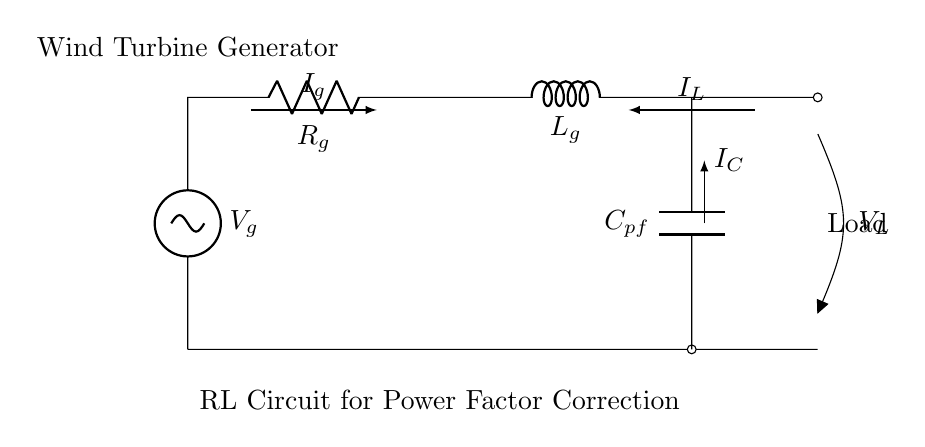What is the voltage source in this circuit? The voltage source is labeled Vg at the top left of the circuit diagram, indicating it provides the input voltage for the RL circuit.
Answer: Vg What component is placed after the resistor? The component that follows the resistor in the circuit layout is an inductor, indicated by the label Lg positioned directly after the resistor Rg.
Answer: Lg What is the purpose of the capacitor in this circuit? The capacitor, labeled Cpf, serves the purpose of power factor correction, helping to improve the circuit's efficiency by compensating for the inductive load created by the inductor Lg.
Answer: Power factor correction What are the current directions in this circuit? The diagram shows that there are three currents: Ig flowing through the generator to the resistor, Il flowing to the load, and Ic flowing through the capacitor. The arrows indicate the direction of current flow in each section.
Answer: Ig, Il, Ic How does the presence of the inductor affect the circuit? The inductor creates a phase difference between the voltage and current, introducing inductive reactance, which can lower the power factor of the overall circuit unless compensated by the capacitor Cpf.
Answer: Lowers power factor What is the relation between the currents Ig and Il? In this RL circuit, the relationship is characterized by conservation of energy, where the current Ig provided by the generator must equal the current Il flowing to the load, moderated through the inductor's effects.
Answer: Ig = Il What does the label on the load represent? The label at the right side of the diagram identifies the load connected to the circuit, which receives power after the RL components. This is where the output of the circuit is utilized.
Answer: Load 